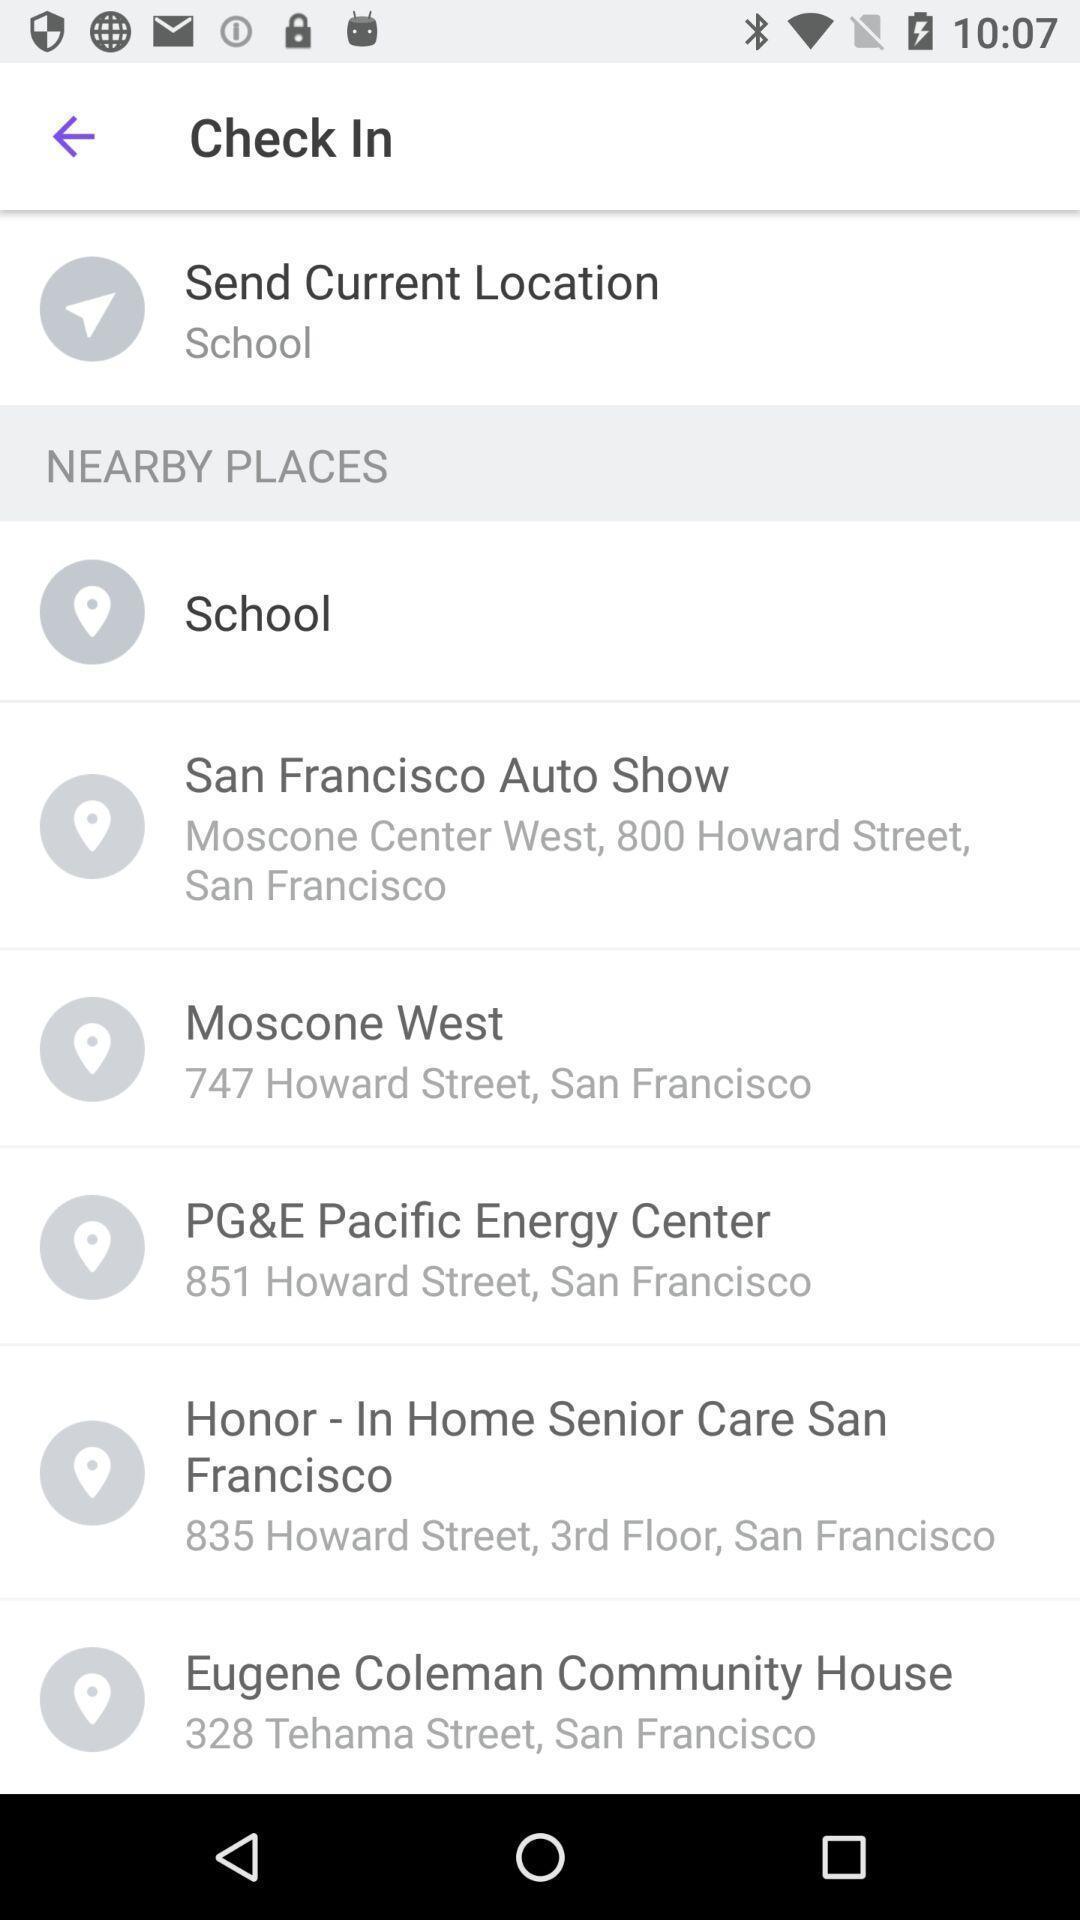Provide a detailed account of this screenshot. Screen displaying list of nearby places. 